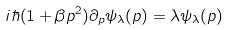<formula> <loc_0><loc_0><loc_500><loc_500>i \hbar { ( } 1 + \beta p ^ { 2 } ) \partial _ { p } \psi _ { \lambda } ( p ) = \lambda \psi _ { \lambda } ( p )</formula> 